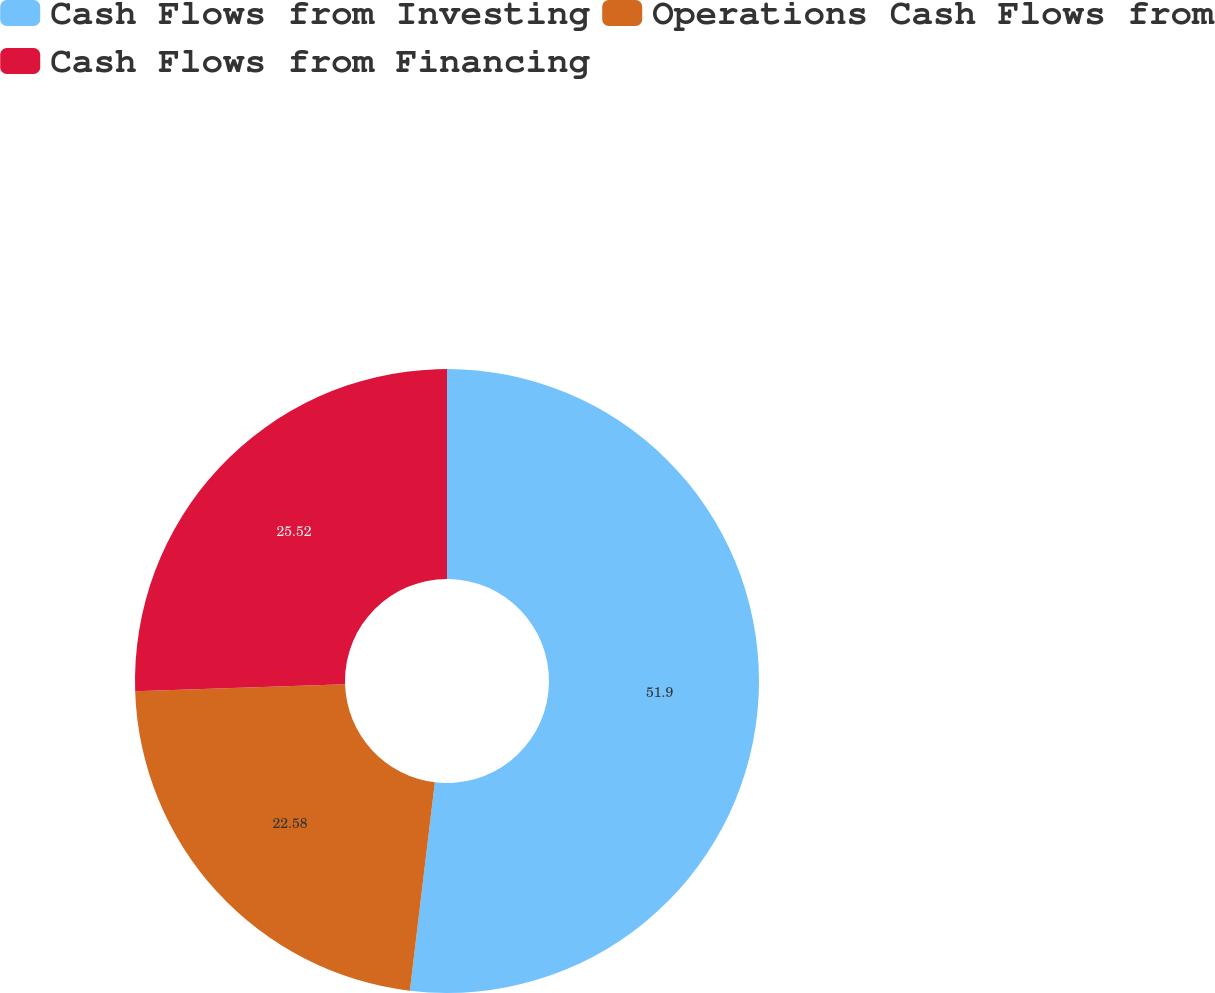<chart> <loc_0><loc_0><loc_500><loc_500><pie_chart><fcel>Cash Flows from Investing<fcel>Operations Cash Flows from<fcel>Cash Flows from Financing<nl><fcel>51.9%<fcel>22.58%<fcel>25.52%<nl></chart> 